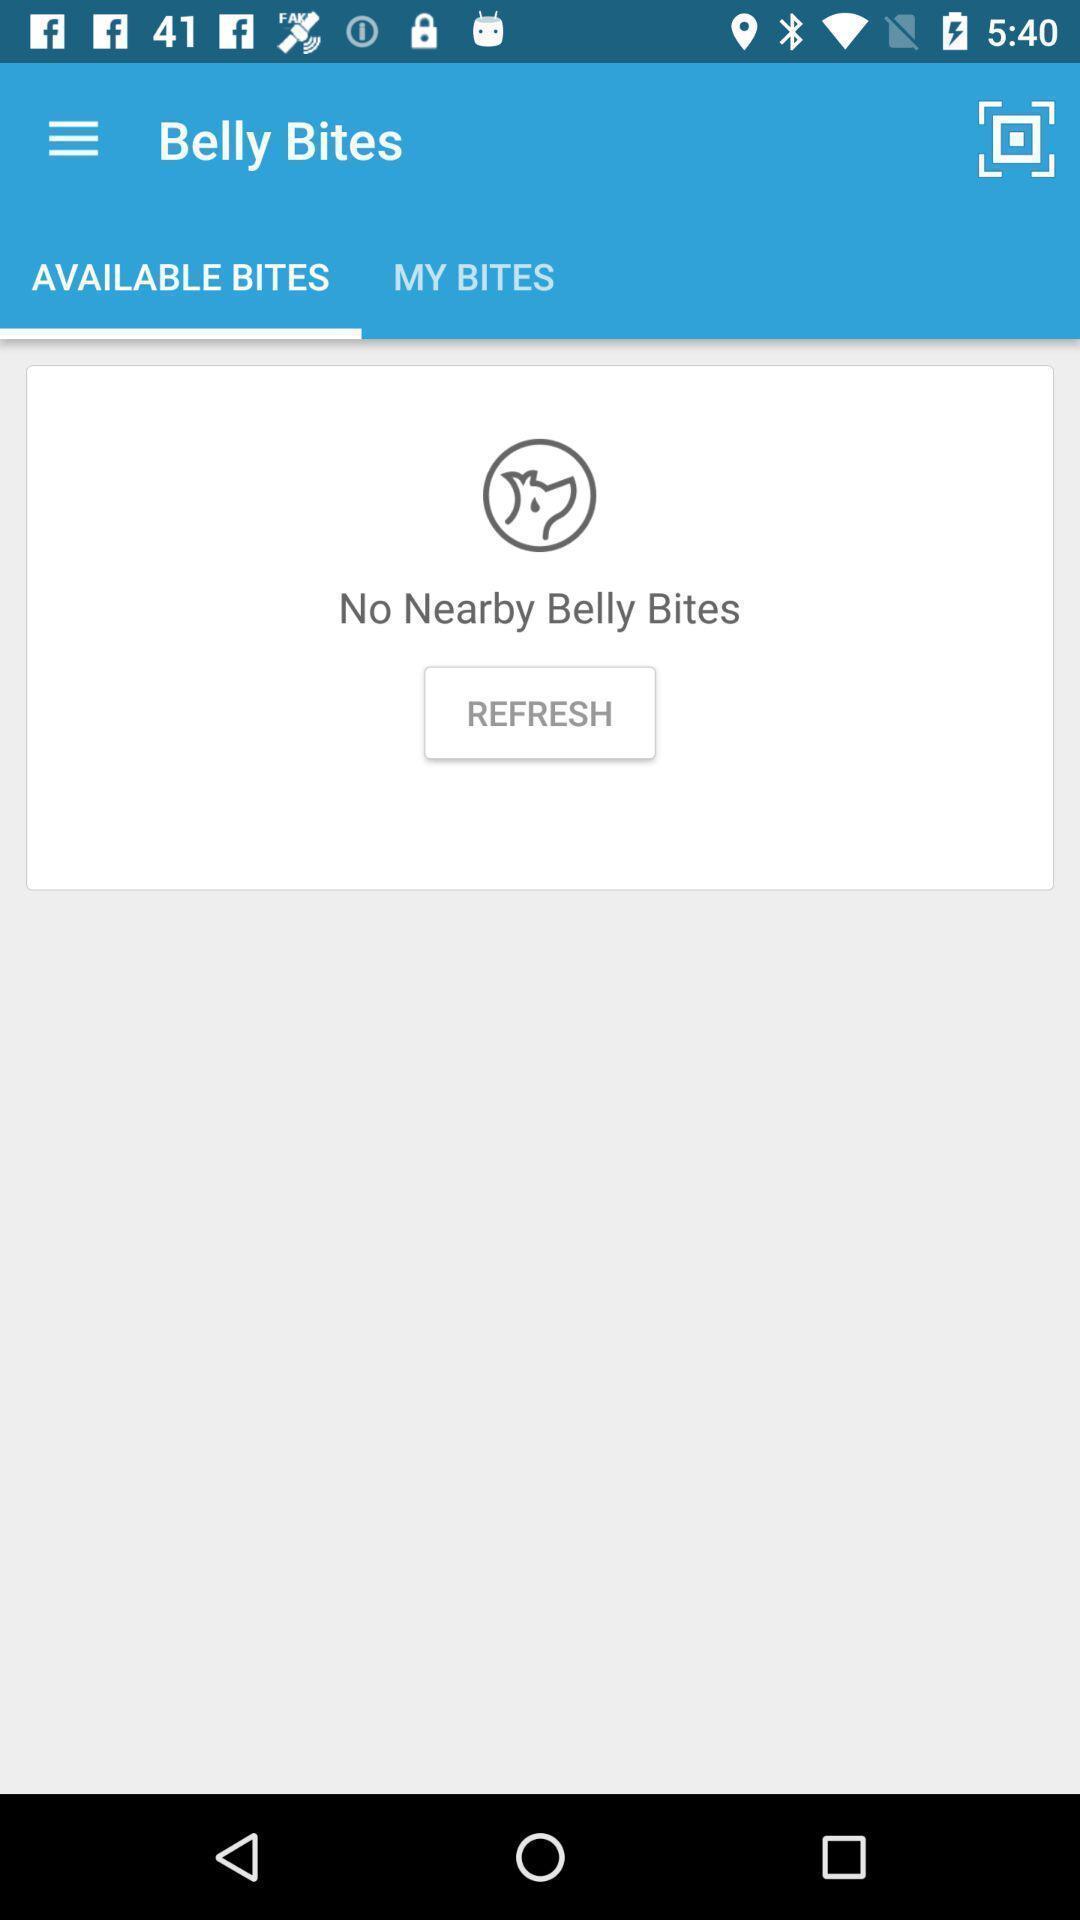Provide a description of this screenshot. Screen displaying the available bites page. 